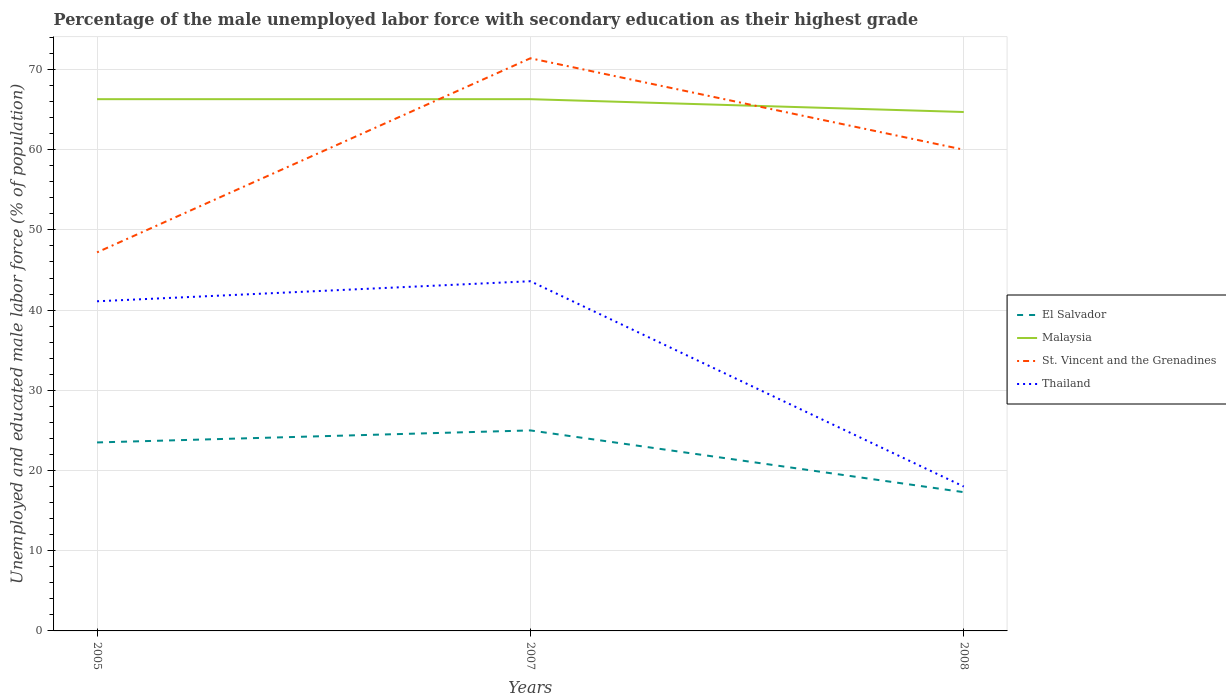Does the line corresponding to Malaysia intersect with the line corresponding to Thailand?
Your response must be concise. No. Is the number of lines equal to the number of legend labels?
Keep it short and to the point. Yes. Across all years, what is the maximum percentage of the unemployed male labor force with secondary education in Malaysia?
Provide a short and direct response. 64.7. In which year was the percentage of the unemployed male labor force with secondary education in El Salvador maximum?
Ensure brevity in your answer.  2008. What is the total percentage of the unemployed male labor force with secondary education in El Salvador in the graph?
Make the answer very short. 7.7. What is the difference between the highest and the second highest percentage of the unemployed male labor force with secondary education in El Salvador?
Your answer should be very brief. 7.7. What is the difference between two consecutive major ticks on the Y-axis?
Offer a terse response. 10. Does the graph contain any zero values?
Offer a very short reply. No. Does the graph contain grids?
Give a very brief answer. Yes. How many legend labels are there?
Ensure brevity in your answer.  4. What is the title of the graph?
Your answer should be compact. Percentage of the male unemployed labor force with secondary education as their highest grade. Does "Jamaica" appear as one of the legend labels in the graph?
Offer a very short reply. No. What is the label or title of the Y-axis?
Offer a very short reply. Unemployed and educated male labor force (% of population). What is the Unemployed and educated male labor force (% of population) in El Salvador in 2005?
Offer a very short reply. 23.5. What is the Unemployed and educated male labor force (% of population) of Malaysia in 2005?
Ensure brevity in your answer.  66.3. What is the Unemployed and educated male labor force (% of population) in St. Vincent and the Grenadines in 2005?
Your answer should be very brief. 47.2. What is the Unemployed and educated male labor force (% of population) of Thailand in 2005?
Offer a very short reply. 41.1. What is the Unemployed and educated male labor force (% of population) in Malaysia in 2007?
Provide a short and direct response. 66.3. What is the Unemployed and educated male labor force (% of population) in St. Vincent and the Grenadines in 2007?
Your answer should be compact. 71.4. What is the Unemployed and educated male labor force (% of population) of Thailand in 2007?
Offer a very short reply. 43.6. What is the Unemployed and educated male labor force (% of population) in El Salvador in 2008?
Your answer should be very brief. 17.3. What is the Unemployed and educated male labor force (% of population) in Malaysia in 2008?
Make the answer very short. 64.7. What is the Unemployed and educated male labor force (% of population) of Thailand in 2008?
Offer a very short reply. 18. Across all years, what is the maximum Unemployed and educated male labor force (% of population) of Malaysia?
Keep it short and to the point. 66.3. Across all years, what is the maximum Unemployed and educated male labor force (% of population) of St. Vincent and the Grenadines?
Give a very brief answer. 71.4. Across all years, what is the maximum Unemployed and educated male labor force (% of population) in Thailand?
Keep it short and to the point. 43.6. Across all years, what is the minimum Unemployed and educated male labor force (% of population) of El Salvador?
Offer a very short reply. 17.3. Across all years, what is the minimum Unemployed and educated male labor force (% of population) of Malaysia?
Your response must be concise. 64.7. Across all years, what is the minimum Unemployed and educated male labor force (% of population) of St. Vincent and the Grenadines?
Your answer should be very brief. 47.2. What is the total Unemployed and educated male labor force (% of population) of El Salvador in the graph?
Keep it short and to the point. 65.8. What is the total Unemployed and educated male labor force (% of population) of Malaysia in the graph?
Your answer should be very brief. 197.3. What is the total Unemployed and educated male labor force (% of population) of St. Vincent and the Grenadines in the graph?
Provide a short and direct response. 178.6. What is the total Unemployed and educated male labor force (% of population) of Thailand in the graph?
Offer a terse response. 102.7. What is the difference between the Unemployed and educated male labor force (% of population) of El Salvador in 2005 and that in 2007?
Give a very brief answer. -1.5. What is the difference between the Unemployed and educated male labor force (% of population) in Malaysia in 2005 and that in 2007?
Keep it short and to the point. 0. What is the difference between the Unemployed and educated male labor force (% of population) in St. Vincent and the Grenadines in 2005 and that in 2007?
Give a very brief answer. -24.2. What is the difference between the Unemployed and educated male labor force (% of population) of Thailand in 2005 and that in 2007?
Make the answer very short. -2.5. What is the difference between the Unemployed and educated male labor force (% of population) of St. Vincent and the Grenadines in 2005 and that in 2008?
Ensure brevity in your answer.  -12.8. What is the difference between the Unemployed and educated male labor force (% of population) of Thailand in 2005 and that in 2008?
Provide a succinct answer. 23.1. What is the difference between the Unemployed and educated male labor force (% of population) of Malaysia in 2007 and that in 2008?
Your answer should be compact. 1.6. What is the difference between the Unemployed and educated male labor force (% of population) in St. Vincent and the Grenadines in 2007 and that in 2008?
Your response must be concise. 11.4. What is the difference between the Unemployed and educated male labor force (% of population) in Thailand in 2007 and that in 2008?
Your response must be concise. 25.6. What is the difference between the Unemployed and educated male labor force (% of population) in El Salvador in 2005 and the Unemployed and educated male labor force (% of population) in Malaysia in 2007?
Your answer should be very brief. -42.8. What is the difference between the Unemployed and educated male labor force (% of population) of El Salvador in 2005 and the Unemployed and educated male labor force (% of population) of St. Vincent and the Grenadines in 2007?
Provide a succinct answer. -47.9. What is the difference between the Unemployed and educated male labor force (% of population) of El Salvador in 2005 and the Unemployed and educated male labor force (% of population) of Thailand in 2007?
Provide a short and direct response. -20.1. What is the difference between the Unemployed and educated male labor force (% of population) in Malaysia in 2005 and the Unemployed and educated male labor force (% of population) in Thailand in 2007?
Your response must be concise. 22.7. What is the difference between the Unemployed and educated male labor force (% of population) in St. Vincent and the Grenadines in 2005 and the Unemployed and educated male labor force (% of population) in Thailand in 2007?
Give a very brief answer. 3.6. What is the difference between the Unemployed and educated male labor force (% of population) in El Salvador in 2005 and the Unemployed and educated male labor force (% of population) in Malaysia in 2008?
Provide a short and direct response. -41.2. What is the difference between the Unemployed and educated male labor force (% of population) of El Salvador in 2005 and the Unemployed and educated male labor force (% of population) of St. Vincent and the Grenadines in 2008?
Keep it short and to the point. -36.5. What is the difference between the Unemployed and educated male labor force (% of population) in Malaysia in 2005 and the Unemployed and educated male labor force (% of population) in St. Vincent and the Grenadines in 2008?
Give a very brief answer. 6.3. What is the difference between the Unemployed and educated male labor force (% of population) in Malaysia in 2005 and the Unemployed and educated male labor force (% of population) in Thailand in 2008?
Your answer should be compact. 48.3. What is the difference between the Unemployed and educated male labor force (% of population) in St. Vincent and the Grenadines in 2005 and the Unemployed and educated male labor force (% of population) in Thailand in 2008?
Make the answer very short. 29.2. What is the difference between the Unemployed and educated male labor force (% of population) in El Salvador in 2007 and the Unemployed and educated male labor force (% of population) in Malaysia in 2008?
Give a very brief answer. -39.7. What is the difference between the Unemployed and educated male labor force (% of population) in El Salvador in 2007 and the Unemployed and educated male labor force (% of population) in St. Vincent and the Grenadines in 2008?
Make the answer very short. -35. What is the difference between the Unemployed and educated male labor force (% of population) in Malaysia in 2007 and the Unemployed and educated male labor force (% of population) in St. Vincent and the Grenadines in 2008?
Offer a very short reply. 6.3. What is the difference between the Unemployed and educated male labor force (% of population) in Malaysia in 2007 and the Unemployed and educated male labor force (% of population) in Thailand in 2008?
Your response must be concise. 48.3. What is the difference between the Unemployed and educated male labor force (% of population) of St. Vincent and the Grenadines in 2007 and the Unemployed and educated male labor force (% of population) of Thailand in 2008?
Offer a terse response. 53.4. What is the average Unemployed and educated male labor force (% of population) in El Salvador per year?
Make the answer very short. 21.93. What is the average Unemployed and educated male labor force (% of population) of Malaysia per year?
Keep it short and to the point. 65.77. What is the average Unemployed and educated male labor force (% of population) of St. Vincent and the Grenadines per year?
Give a very brief answer. 59.53. What is the average Unemployed and educated male labor force (% of population) of Thailand per year?
Ensure brevity in your answer.  34.23. In the year 2005, what is the difference between the Unemployed and educated male labor force (% of population) in El Salvador and Unemployed and educated male labor force (% of population) in Malaysia?
Make the answer very short. -42.8. In the year 2005, what is the difference between the Unemployed and educated male labor force (% of population) of El Salvador and Unemployed and educated male labor force (% of population) of St. Vincent and the Grenadines?
Keep it short and to the point. -23.7. In the year 2005, what is the difference between the Unemployed and educated male labor force (% of population) in El Salvador and Unemployed and educated male labor force (% of population) in Thailand?
Provide a short and direct response. -17.6. In the year 2005, what is the difference between the Unemployed and educated male labor force (% of population) of Malaysia and Unemployed and educated male labor force (% of population) of St. Vincent and the Grenadines?
Offer a terse response. 19.1. In the year 2005, what is the difference between the Unemployed and educated male labor force (% of population) of Malaysia and Unemployed and educated male labor force (% of population) of Thailand?
Offer a terse response. 25.2. In the year 2005, what is the difference between the Unemployed and educated male labor force (% of population) of St. Vincent and the Grenadines and Unemployed and educated male labor force (% of population) of Thailand?
Offer a terse response. 6.1. In the year 2007, what is the difference between the Unemployed and educated male labor force (% of population) in El Salvador and Unemployed and educated male labor force (% of population) in Malaysia?
Make the answer very short. -41.3. In the year 2007, what is the difference between the Unemployed and educated male labor force (% of population) in El Salvador and Unemployed and educated male labor force (% of population) in St. Vincent and the Grenadines?
Your response must be concise. -46.4. In the year 2007, what is the difference between the Unemployed and educated male labor force (% of population) in El Salvador and Unemployed and educated male labor force (% of population) in Thailand?
Your answer should be compact. -18.6. In the year 2007, what is the difference between the Unemployed and educated male labor force (% of population) in Malaysia and Unemployed and educated male labor force (% of population) in St. Vincent and the Grenadines?
Offer a very short reply. -5.1. In the year 2007, what is the difference between the Unemployed and educated male labor force (% of population) in Malaysia and Unemployed and educated male labor force (% of population) in Thailand?
Provide a succinct answer. 22.7. In the year 2007, what is the difference between the Unemployed and educated male labor force (% of population) in St. Vincent and the Grenadines and Unemployed and educated male labor force (% of population) in Thailand?
Offer a very short reply. 27.8. In the year 2008, what is the difference between the Unemployed and educated male labor force (% of population) in El Salvador and Unemployed and educated male labor force (% of population) in Malaysia?
Ensure brevity in your answer.  -47.4. In the year 2008, what is the difference between the Unemployed and educated male labor force (% of population) of El Salvador and Unemployed and educated male labor force (% of population) of St. Vincent and the Grenadines?
Keep it short and to the point. -42.7. In the year 2008, what is the difference between the Unemployed and educated male labor force (% of population) in Malaysia and Unemployed and educated male labor force (% of population) in Thailand?
Your answer should be compact. 46.7. What is the ratio of the Unemployed and educated male labor force (% of population) in El Salvador in 2005 to that in 2007?
Offer a terse response. 0.94. What is the ratio of the Unemployed and educated male labor force (% of population) of Malaysia in 2005 to that in 2007?
Keep it short and to the point. 1. What is the ratio of the Unemployed and educated male labor force (% of population) in St. Vincent and the Grenadines in 2005 to that in 2007?
Ensure brevity in your answer.  0.66. What is the ratio of the Unemployed and educated male labor force (% of population) in Thailand in 2005 to that in 2007?
Ensure brevity in your answer.  0.94. What is the ratio of the Unemployed and educated male labor force (% of population) of El Salvador in 2005 to that in 2008?
Offer a very short reply. 1.36. What is the ratio of the Unemployed and educated male labor force (% of population) of Malaysia in 2005 to that in 2008?
Your answer should be compact. 1.02. What is the ratio of the Unemployed and educated male labor force (% of population) of St. Vincent and the Grenadines in 2005 to that in 2008?
Keep it short and to the point. 0.79. What is the ratio of the Unemployed and educated male labor force (% of population) of Thailand in 2005 to that in 2008?
Offer a very short reply. 2.28. What is the ratio of the Unemployed and educated male labor force (% of population) of El Salvador in 2007 to that in 2008?
Give a very brief answer. 1.45. What is the ratio of the Unemployed and educated male labor force (% of population) of Malaysia in 2007 to that in 2008?
Make the answer very short. 1.02. What is the ratio of the Unemployed and educated male labor force (% of population) in St. Vincent and the Grenadines in 2007 to that in 2008?
Your answer should be very brief. 1.19. What is the ratio of the Unemployed and educated male labor force (% of population) in Thailand in 2007 to that in 2008?
Your response must be concise. 2.42. What is the difference between the highest and the second highest Unemployed and educated male labor force (% of population) of El Salvador?
Provide a short and direct response. 1.5. What is the difference between the highest and the second highest Unemployed and educated male labor force (% of population) in Malaysia?
Give a very brief answer. 0. What is the difference between the highest and the second highest Unemployed and educated male labor force (% of population) in St. Vincent and the Grenadines?
Give a very brief answer. 11.4. What is the difference between the highest and the second highest Unemployed and educated male labor force (% of population) in Thailand?
Your answer should be compact. 2.5. What is the difference between the highest and the lowest Unemployed and educated male labor force (% of population) in El Salvador?
Provide a succinct answer. 7.7. What is the difference between the highest and the lowest Unemployed and educated male labor force (% of population) in Malaysia?
Make the answer very short. 1.6. What is the difference between the highest and the lowest Unemployed and educated male labor force (% of population) in St. Vincent and the Grenadines?
Keep it short and to the point. 24.2. What is the difference between the highest and the lowest Unemployed and educated male labor force (% of population) of Thailand?
Make the answer very short. 25.6. 